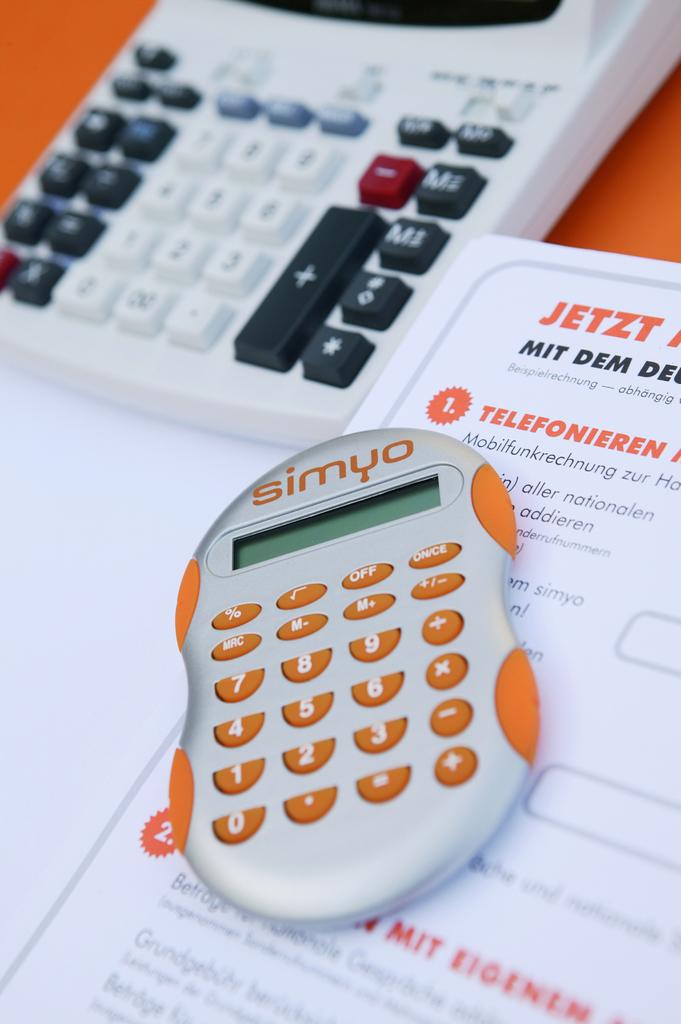What brand of calculator is this?
Provide a short and direct response. Simyo. What word is in orange on the top left of the paper?
Give a very brief answer. Jetzt. 